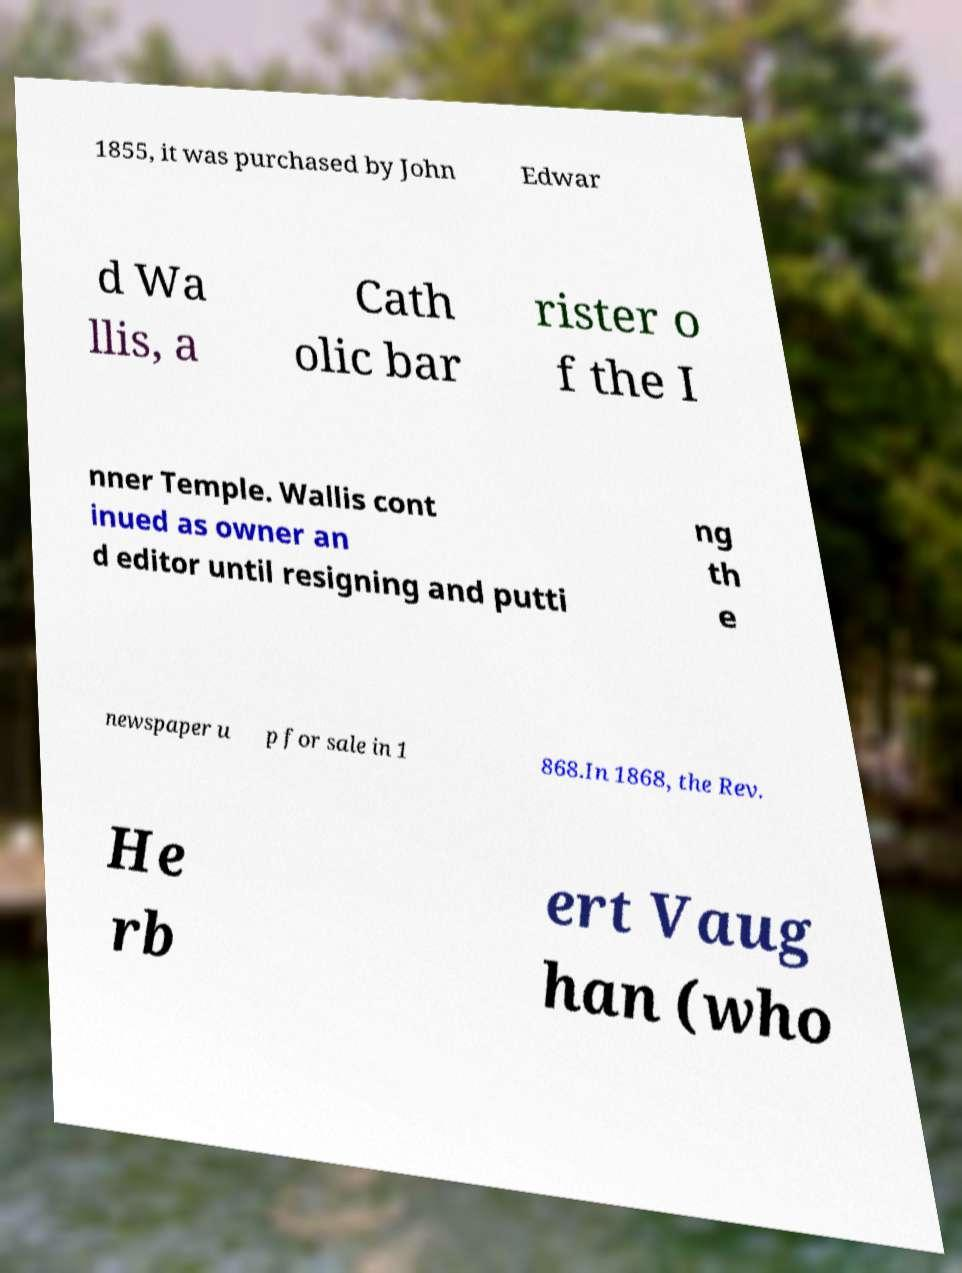Can you read and provide the text displayed in the image?This photo seems to have some interesting text. Can you extract and type it out for me? 1855, it was purchased by John Edwar d Wa llis, a Cath olic bar rister o f the I nner Temple. Wallis cont inued as owner an d editor until resigning and putti ng th e newspaper u p for sale in 1 868.In 1868, the Rev. He rb ert Vaug han (who 